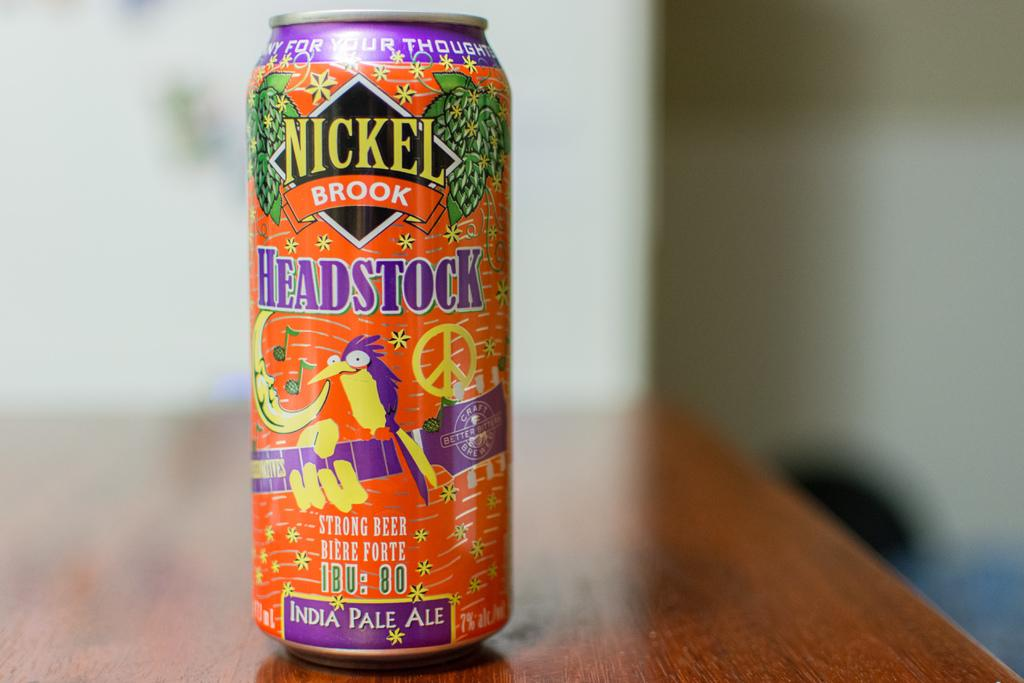<image>
Summarize the visual content of the image. the Nickel Brook can that is on a table 